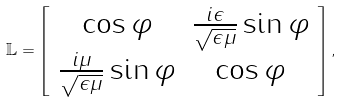Convert formula to latex. <formula><loc_0><loc_0><loc_500><loc_500>\mathbb { L } = \left [ \begin{array} { c c } \cos \varphi & \frac { i \epsilon } { \sqrt { \epsilon \mu } } \sin \varphi \\ \frac { i \mu } { \sqrt { \epsilon \mu } } \sin \varphi & \cos \varphi \end{array} \right ] ,</formula> 